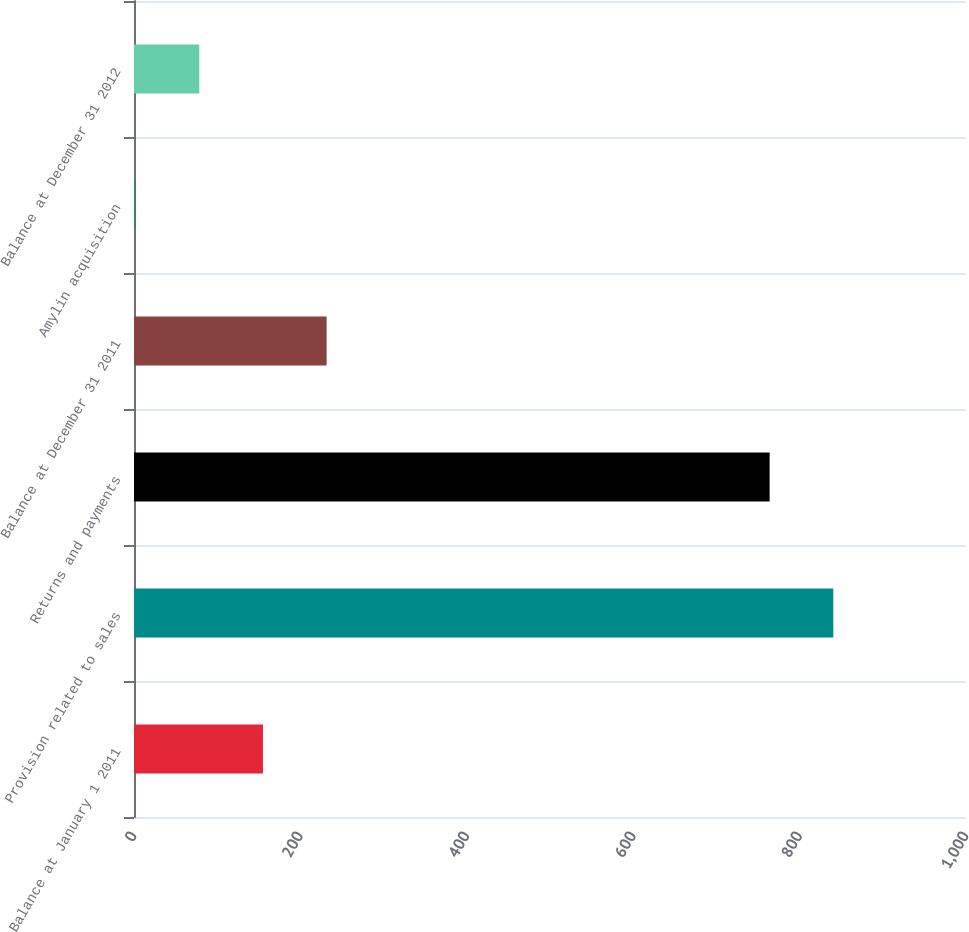Convert chart to OTSL. <chart><loc_0><loc_0><loc_500><loc_500><bar_chart><fcel>Balance at January 1 2011<fcel>Provision related to sales<fcel>Returns and payments<fcel>Balance at December 31 2011<fcel>Amylin acquisition<fcel>Balance at December 31 2012<nl><fcel>155<fcel>840.5<fcel>764<fcel>231.5<fcel>2<fcel>78.5<nl></chart> 